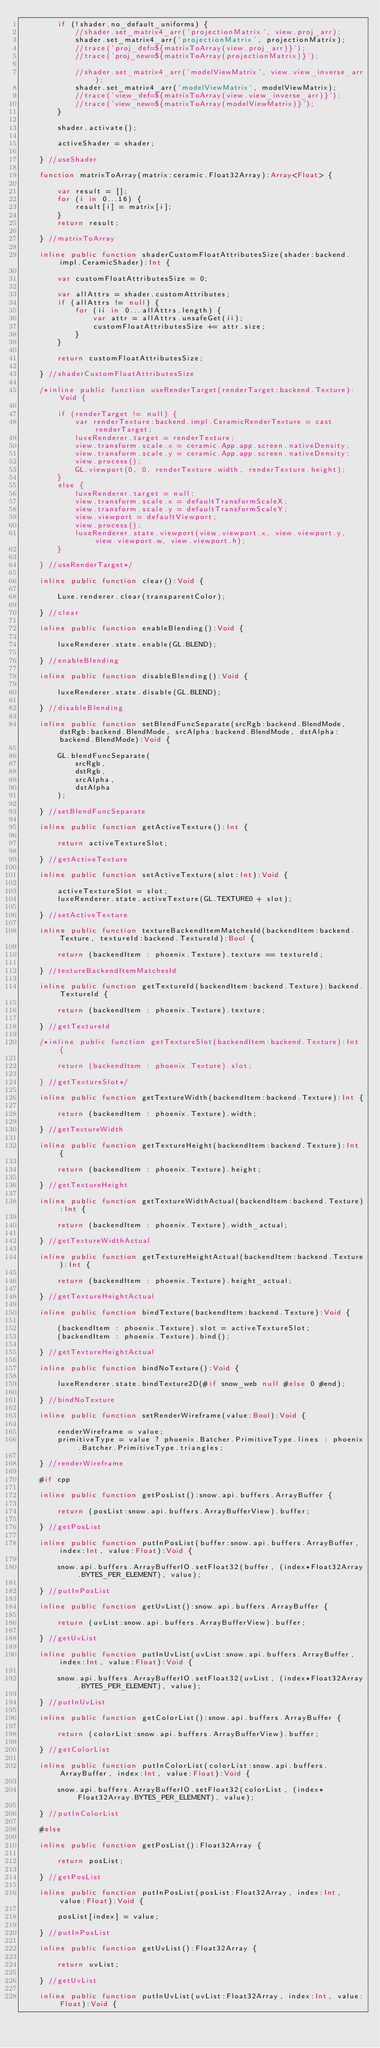Convert code to text. <code><loc_0><loc_0><loc_500><loc_500><_Haxe_>        if (!shader.no_default_uniforms) {
            //shader.set_matrix4_arr('projectionMatrix', view.proj_arr);
            shader.set_matrix4_arr('projectionMatrix', projectionMatrix);
            //trace('proj_def=${matrixToArray(view.proj_arr)}');
            //trace('proj_new=${matrixToArray(projectionMatrix)}');

            //shader.set_matrix4_arr('modelViewMatrix', view.view_inverse_arr);
            shader.set_matrix4_arr('modelViewMatrix', modelViewMatrix);
            //trace('view_def=${matrixToArray(view.view_inverse_arr)}');
            //trace('view_new=${matrixToArray(modelViewMatrix)}');
        }
        
        shader.activate();
        
        activeShader = shader;

    } //useShader

    function matrixToArray(matrix:ceramic.Float32Array):Array<Float> {

        var result = [];
        for (i in 0...16) {
            result[i] = matrix[i];
        }
        return result;

    } //matrixToArray

    inline public function shaderCustomFloatAttributesSize(shader:backend.impl.CeramicShader):Int {

        var customFloatAttributesSize = 0;

        var allAttrs = shader.customAttributes;
        if (allAttrs != null) {
            for (ii in 0...allAttrs.length) {
                var attr = allAttrs.unsafeGet(ii);
                customFloatAttributesSize += attr.size;
            }
        }

        return customFloatAttributesSize;

    } //shaderCustomFloatAttributesSize

    /*inline public function useRenderTarget(renderTarget:backend.Texture):Void {

        if (renderTarget != null) {
            var renderTexture:backend.impl.CeramicRenderTexture = cast renderTarget;
            luxeRenderer.target = renderTexture;
            view.transform.scale.x = ceramic.App.app.screen.nativeDensity;
            view.transform.scale.y = ceramic.App.app.screen.nativeDensity;
            view.process();
            GL.viewport(0, 0, renderTexture.width, renderTexture.height);
        }
        else {
            luxeRenderer.target = null;
            view.transform.scale.x = defaultTransformScaleX;
            view.transform.scale.y = defaultTransformScaleY;
            view.viewport = defaultViewport;
            view.process();
            luxeRenderer.state.viewport(view.viewport.x, view.viewport.y, view.viewport.w, view.viewport.h);
        }

    } //useRenderTarget*/

    inline public function clear():Void {

        Luxe.renderer.clear(transparentColor);

    } //clear

    inline public function enableBlending():Void {

        luxeRenderer.state.enable(GL.BLEND);

    } //enableBlending

    inline public function disableBlending():Void {

        luxeRenderer.state.disable(GL.BLEND);

    } //disableBlending

    inline public function setBlendFuncSeparate(srcRgb:backend.BlendMode, dstRgb:backend.BlendMode, srcAlpha:backend.BlendMode, dstAlpha:backend.BlendMode):Void {

        GL.blendFuncSeparate(
            srcRgb,
            dstRgb,
            srcAlpha,
            dstAlpha
        );

    } //setBlendFuncSeparate

    inline public function getActiveTexture():Int {

        return activeTextureSlot;

    } //getActiveTexture

    inline public function setActiveTexture(slot:Int):Void {

        activeTextureSlot = slot;
        luxeRenderer.state.activeTexture(GL.TEXTURE0 + slot);

    } //setActiveTexture

    inline public function textureBackendItemMatchesId(backendItem:backend.Texture, textureId:backend.TextureId):Bool {

        return (backendItem : phoenix.Texture).texture == textureId;

    } //textureBackendItemMatchesId

    inline public function getTextureId(backendItem:backend.Texture):backend.TextureId {

        return (backendItem : phoenix.Texture).texture;

    } //getTextureId

    /*inline public function getTextureSlot(backendItem:backend.Texture):Int {

        return (backendItem : phoenix.Texture).slot;

    } //getTextureSlot*/

    inline public function getTextureWidth(backendItem:backend.Texture):Int {

        return (backendItem : phoenix.Texture).width;

    } //getTextureWidth

    inline public function getTextureHeight(backendItem:backend.Texture):Int {

        return (backendItem : phoenix.Texture).height;

    } //getTextureHeight

    inline public function getTextureWidthActual(backendItem:backend.Texture):Int {

        return (backendItem : phoenix.Texture).width_actual;

    } //getTextureWidthActual

    inline public function getTextureHeightActual(backendItem:backend.Texture):Int {

        return (backendItem : phoenix.Texture).height_actual;

    } //getTextureHeightActual

    inline public function bindTexture(backendItem:backend.Texture):Void {

        (backendItem : phoenix.Texture).slot = activeTextureSlot;
        (backendItem : phoenix.Texture).bind();

    } //getTextureHeightActual

    inline public function bindNoTexture():Void {

        luxeRenderer.state.bindTexture2D(#if snow_web null #else 0 #end);

    } //bindNoTexture

    inline public function setRenderWireframe(value:Bool):Void {

        renderWireframe = value;
        primitiveType = value ? phoenix.Batcher.PrimitiveType.lines : phoenix.Batcher.PrimitiveType.triangles;

    } //renderWireframe

    #if cpp

    inline public function getPosList():snow.api.buffers.ArrayBuffer {

        return (posList:snow.api.buffers.ArrayBufferView).buffer;

    } //getPosList

    inline public function putInPosList(buffer:snow.api.buffers.ArrayBuffer, index:Int, value:Float):Void {

        snow.api.buffers.ArrayBufferIO.setFloat32(buffer, (index*Float32Array.BYTES_PER_ELEMENT), value);

    } //putInPosList

    inline public function getUvList():snow.api.buffers.ArrayBuffer {

        return (uvList:snow.api.buffers.ArrayBufferView).buffer;

    } //getUvList

    inline public function putInUvList(uvList:snow.api.buffers.ArrayBuffer, index:Int, value:Float):Void {

        snow.api.buffers.ArrayBufferIO.setFloat32(uvList, (index*Float32Array.BYTES_PER_ELEMENT), value);

    } //putInUvList

    inline public function getColorList():snow.api.buffers.ArrayBuffer {

        return (colorList:snow.api.buffers.ArrayBufferView).buffer;

    } //getColorList

    inline public function putInColorList(colorList:snow.api.buffers.ArrayBuffer, index:Int, value:Float):Void {

        snow.api.buffers.ArrayBufferIO.setFloat32(colorList, (index*Float32Array.BYTES_PER_ELEMENT), value);

    } //putInColorList

    #else

    inline public function getPosList():Float32Array {

        return posList;

    } //getPosList

    inline public function putInPosList(posList:Float32Array, index:Int, value:Float):Void {

        posList[index] = value;

    } //putInPosList

    inline public function getUvList():Float32Array {

        return uvList;

    } //getUvList

    inline public function putInUvList(uvList:Float32Array, index:Int, value:Float):Void {
</code> 